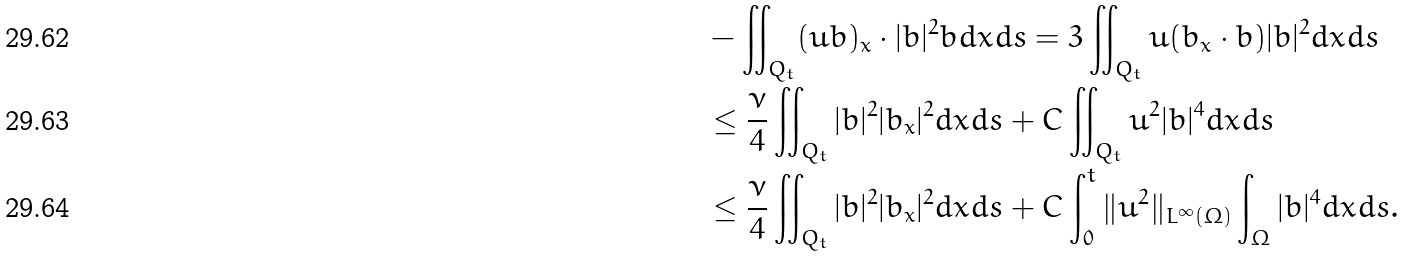<formula> <loc_0><loc_0><loc_500><loc_500>& - \iint _ { Q _ { t } } ( u b ) _ { x } \cdot | b | ^ { 2 } b d x d s = 3 \iint _ { Q _ { t } } u ( b _ { x } \cdot b ) | b | ^ { 2 } d x d s \\ & \leq \frac { \nu } { 4 } \iint _ { Q _ { t } } | b | ^ { 2 } | b _ { x } | ^ { 2 } d x d s + C \iint _ { Q _ { t } } u ^ { 2 } | b | ^ { 4 } d x d s \\ & \leq \frac { \nu } { 4 } \iint _ { Q _ { t } } | b | ^ { 2 } | b _ { x } | ^ { 2 } d x d s + C \int _ { 0 } ^ { t } \| u ^ { 2 } \| _ { L ^ { \infty } ( \Omega ) } \int _ { \Omega } | b | ^ { 4 } d x d s .</formula> 